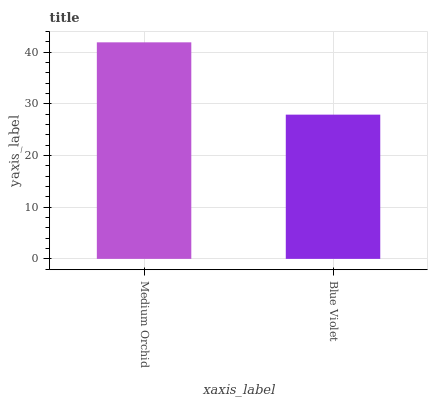Is Blue Violet the minimum?
Answer yes or no. Yes. Is Medium Orchid the maximum?
Answer yes or no. Yes. Is Blue Violet the maximum?
Answer yes or no. No. Is Medium Orchid greater than Blue Violet?
Answer yes or no. Yes. Is Blue Violet less than Medium Orchid?
Answer yes or no. Yes. Is Blue Violet greater than Medium Orchid?
Answer yes or no. No. Is Medium Orchid less than Blue Violet?
Answer yes or no. No. Is Medium Orchid the high median?
Answer yes or no. Yes. Is Blue Violet the low median?
Answer yes or no. Yes. Is Blue Violet the high median?
Answer yes or no. No. Is Medium Orchid the low median?
Answer yes or no. No. 